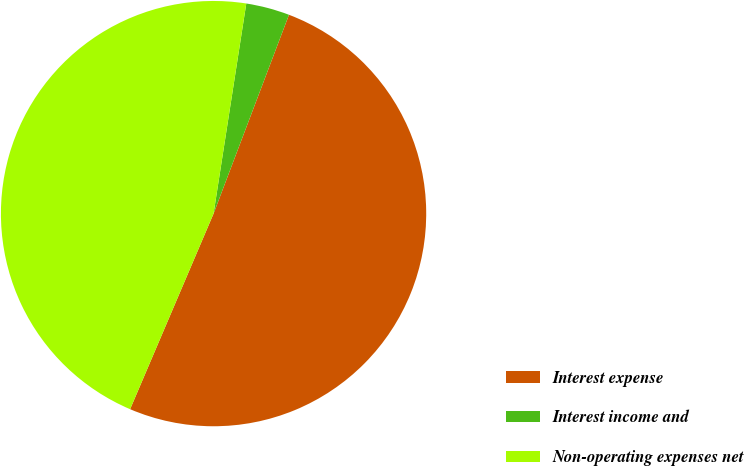Convert chart to OTSL. <chart><loc_0><loc_0><loc_500><loc_500><pie_chart><fcel>Interest expense<fcel>Interest income and<fcel>Non-operating expenses net<nl><fcel>50.65%<fcel>3.31%<fcel>46.04%<nl></chart> 